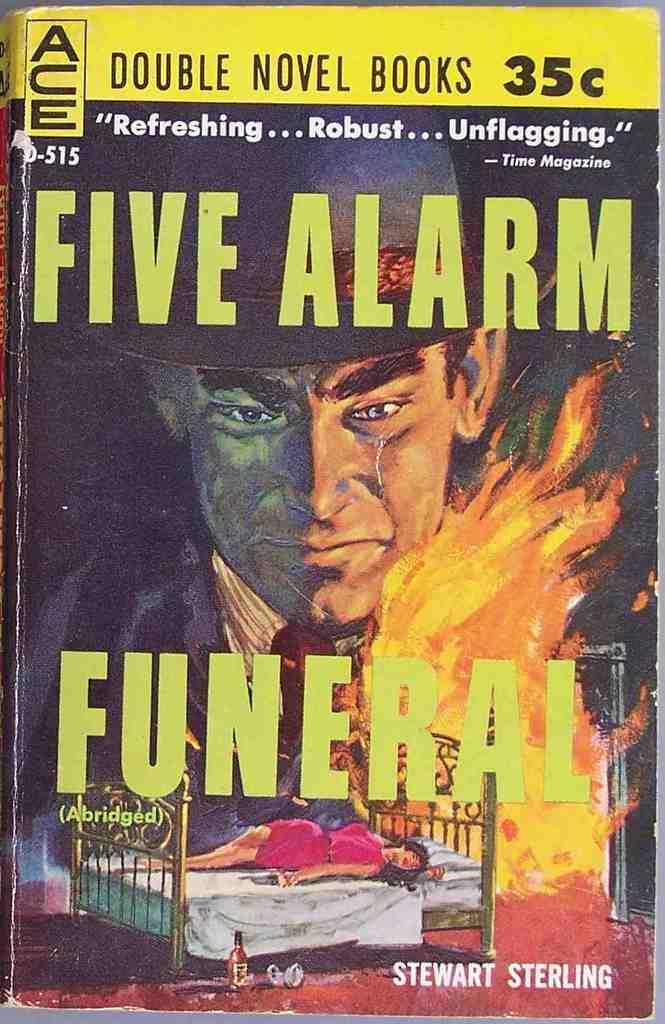How much did this cost?
Offer a very short reply. 35 cents. What is the name of this book?
Offer a very short reply. Five alarm funeral. 